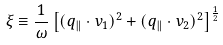Convert formula to latex. <formula><loc_0><loc_0><loc_500><loc_500>\xi \equiv \frac { 1 } { \omega } \left [ ( { q } _ { \| } \cdot { v } _ { 1 } ) ^ { 2 } + ( { q } _ { \| } \cdot { v } _ { 2 } ) ^ { 2 } \right ] ^ { \frac { 1 } { 2 } }</formula> 